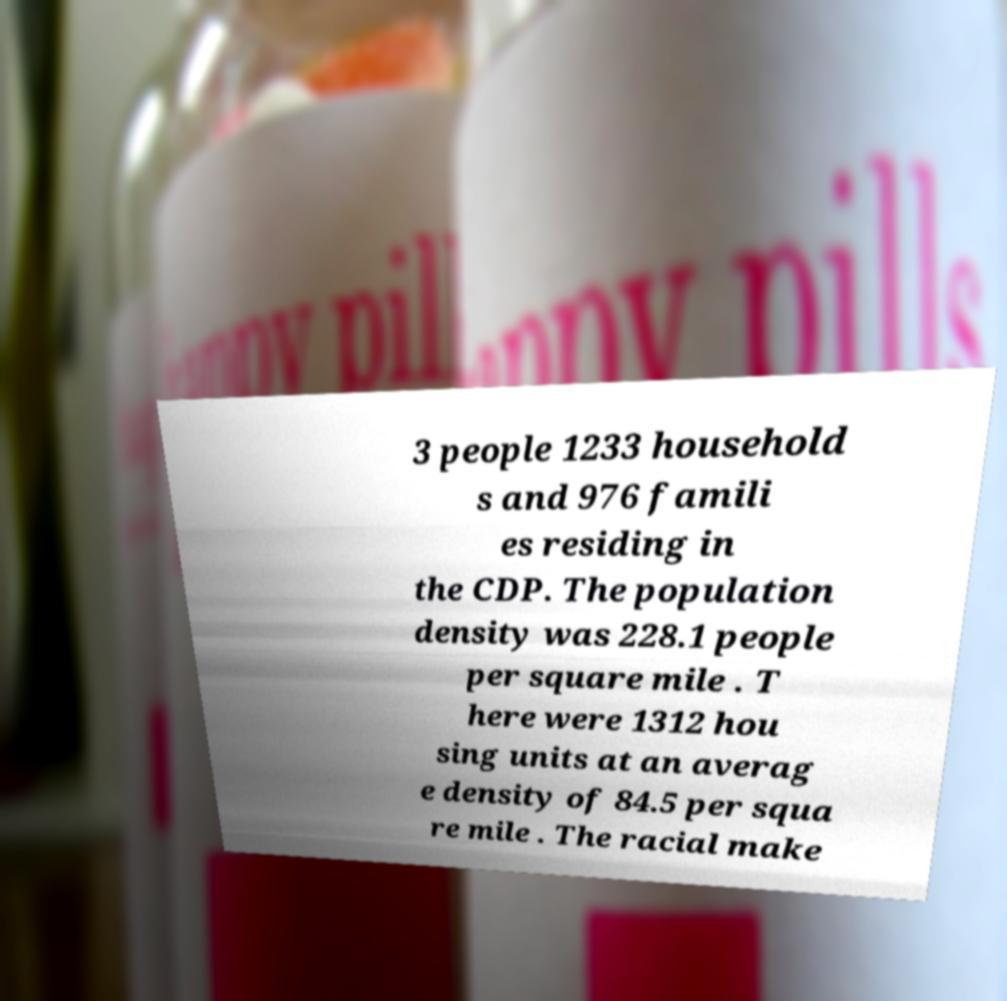Please read and relay the text visible in this image. What does it say? 3 people 1233 household s and 976 famili es residing in the CDP. The population density was 228.1 people per square mile . T here were 1312 hou sing units at an averag e density of 84.5 per squa re mile . The racial make 